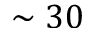Convert formula to latex. <formula><loc_0><loc_0><loc_500><loc_500>\sim 3 0</formula> 